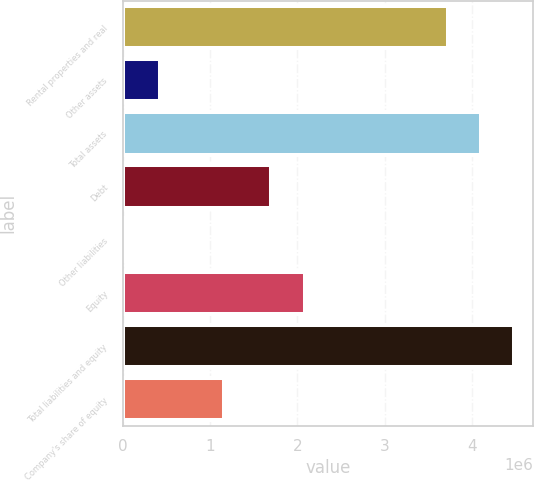Convert chart to OTSL. <chart><loc_0><loc_0><loc_500><loc_500><bar_chart><fcel>Rental properties and real<fcel>Other assets<fcel>Total assets<fcel>Debt<fcel>Other liabilities<fcel>Equity<fcel>Total liabilities and equity<fcel>Company's share of equity<nl><fcel>3.72278e+06<fcel>424275<fcel>4.10154e+06<fcel>1.70505e+06<fcel>45515<fcel>2.08381e+06<fcel>4.4803e+06<fcel>1.15598e+06<nl></chart> 